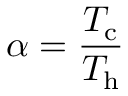Convert formula to latex. <formula><loc_0><loc_0><loc_500><loc_500>\alpha = \frac { T _ { c } } { T _ { h } }</formula> 